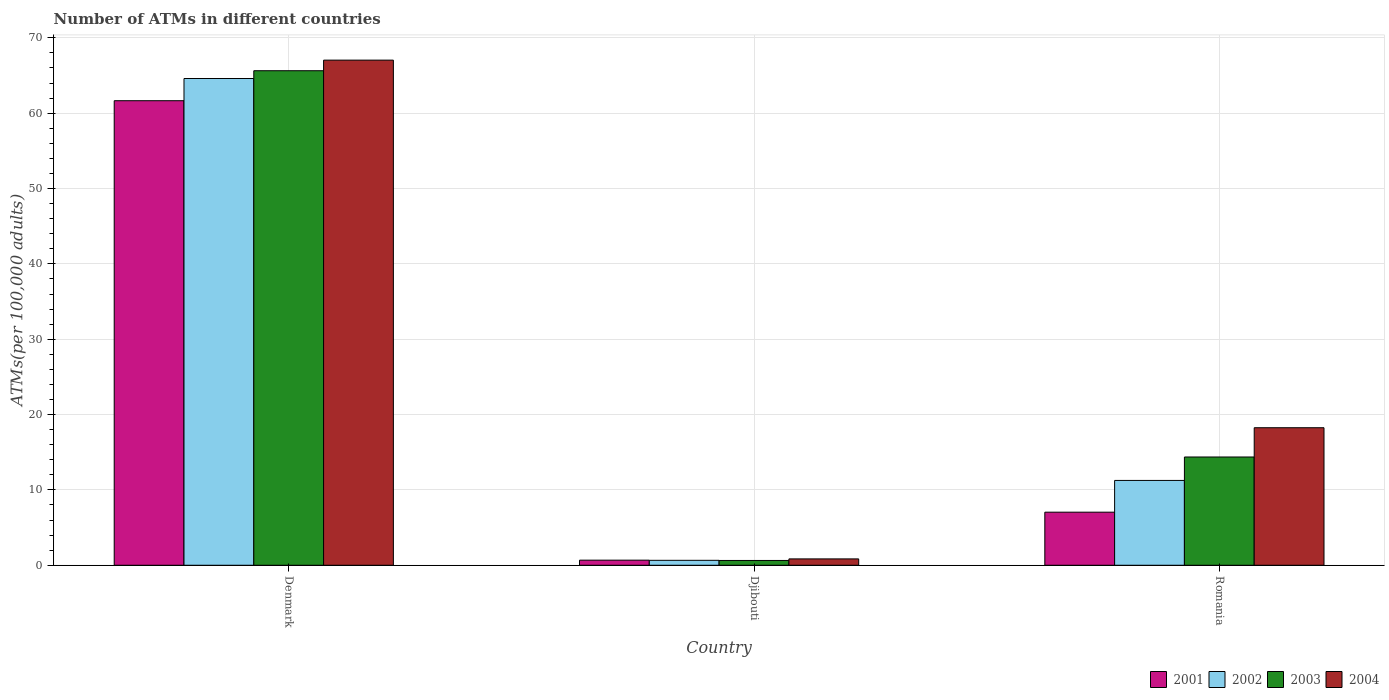How many groups of bars are there?
Your answer should be very brief. 3. Are the number of bars on each tick of the X-axis equal?
Make the answer very short. Yes. How many bars are there on the 2nd tick from the right?
Your answer should be compact. 4. What is the label of the 2nd group of bars from the left?
Ensure brevity in your answer.  Djibouti. What is the number of ATMs in 2004 in Romania?
Your response must be concise. 18.26. Across all countries, what is the maximum number of ATMs in 2002?
Keep it short and to the point. 64.61. Across all countries, what is the minimum number of ATMs in 2001?
Offer a terse response. 0.68. In which country was the number of ATMs in 2002 maximum?
Give a very brief answer. Denmark. In which country was the number of ATMs in 2002 minimum?
Your answer should be very brief. Djibouti. What is the total number of ATMs in 2003 in the graph?
Your response must be concise. 80.65. What is the difference between the number of ATMs in 2003 in Djibouti and that in Romania?
Give a very brief answer. -13.73. What is the difference between the number of ATMs in 2001 in Denmark and the number of ATMs in 2002 in Romania?
Offer a terse response. 50.4. What is the average number of ATMs in 2001 per country?
Provide a short and direct response. 23.13. What is the difference between the number of ATMs of/in 2001 and number of ATMs of/in 2002 in Djibouti?
Ensure brevity in your answer.  0.02. What is the ratio of the number of ATMs in 2003 in Djibouti to that in Romania?
Your answer should be very brief. 0.04. Is the number of ATMs in 2004 in Djibouti less than that in Romania?
Offer a terse response. Yes. What is the difference between the highest and the second highest number of ATMs in 2004?
Offer a very short reply. -17.41. What is the difference between the highest and the lowest number of ATMs in 2002?
Your response must be concise. 63.95. In how many countries, is the number of ATMs in 2002 greater than the average number of ATMs in 2002 taken over all countries?
Offer a terse response. 1. Is the sum of the number of ATMs in 2001 in Denmark and Djibouti greater than the maximum number of ATMs in 2003 across all countries?
Offer a terse response. No. Is it the case that in every country, the sum of the number of ATMs in 2001 and number of ATMs in 2003 is greater than the sum of number of ATMs in 2004 and number of ATMs in 2002?
Give a very brief answer. No. What does the 2nd bar from the left in Djibouti represents?
Your response must be concise. 2002. What does the 4th bar from the right in Djibouti represents?
Your answer should be compact. 2001. Is it the case that in every country, the sum of the number of ATMs in 2001 and number of ATMs in 2003 is greater than the number of ATMs in 2002?
Your answer should be very brief. Yes. What is the title of the graph?
Give a very brief answer. Number of ATMs in different countries. What is the label or title of the X-axis?
Make the answer very short. Country. What is the label or title of the Y-axis?
Give a very brief answer. ATMs(per 100,0 adults). What is the ATMs(per 100,000 adults) in 2001 in Denmark?
Ensure brevity in your answer.  61.66. What is the ATMs(per 100,000 adults) of 2002 in Denmark?
Your answer should be very brief. 64.61. What is the ATMs(per 100,000 adults) in 2003 in Denmark?
Provide a short and direct response. 65.64. What is the ATMs(per 100,000 adults) of 2004 in Denmark?
Your response must be concise. 67.04. What is the ATMs(per 100,000 adults) in 2001 in Djibouti?
Keep it short and to the point. 0.68. What is the ATMs(per 100,000 adults) of 2002 in Djibouti?
Your answer should be very brief. 0.66. What is the ATMs(per 100,000 adults) in 2003 in Djibouti?
Keep it short and to the point. 0.64. What is the ATMs(per 100,000 adults) in 2004 in Djibouti?
Provide a short and direct response. 0.84. What is the ATMs(per 100,000 adults) in 2001 in Romania?
Provide a short and direct response. 7.04. What is the ATMs(per 100,000 adults) in 2002 in Romania?
Give a very brief answer. 11.26. What is the ATMs(per 100,000 adults) of 2003 in Romania?
Make the answer very short. 14.37. What is the ATMs(per 100,000 adults) of 2004 in Romania?
Offer a very short reply. 18.26. Across all countries, what is the maximum ATMs(per 100,000 adults) in 2001?
Offer a very short reply. 61.66. Across all countries, what is the maximum ATMs(per 100,000 adults) of 2002?
Keep it short and to the point. 64.61. Across all countries, what is the maximum ATMs(per 100,000 adults) of 2003?
Ensure brevity in your answer.  65.64. Across all countries, what is the maximum ATMs(per 100,000 adults) in 2004?
Provide a short and direct response. 67.04. Across all countries, what is the minimum ATMs(per 100,000 adults) of 2001?
Provide a short and direct response. 0.68. Across all countries, what is the minimum ATMs(per 100,000 adults) in 2002?
Give a very brief answer. 0.66. Across all countries, what is the minimum ATMs(per 100,000 adults) of 2003?
Your response must be concise. 0.64. Across all countries, what is the minimum ATMs(per 100,000 adults) of 2004?
Your answer should be compact. 0.84. What is the total ATMs(per 100,000 adults) in 2001 in the graph?
Offer a terse response. 69.38. What is the total ATMs(per 100,000 adults) in 2002 in the graph?
Give a very brief answer. 76.52. What is the total ATMs(per 100,000 adults) of 2003 in the graph?
Your answer should be compact. 80.65. What is the total ATMs(per 100,000 adults) in 2004 in the graph?
Ensure brevity in your answer.  86.14. What is the difference between the ATMs(per 100,000 adults) in 2001 in Denmark and that in Djibouti?
Your answer should be compact. 60.98. What is the difference between the ATMs(per 100,000 adults) of 2002 in Denmark and that in Djibouti?
Ensure brevity in your answer.  63.95. What is the difference between the ATMs(per 100,000 adults) of 2003 in Denmark and that in Djibouti?
Give a very brief answer. 65. What is the difference between the ATMs(per 100,000 adults) of 2004 in Denmark and that in Djibouti?
Ensure brevity in your answer.  66.2. What is the difference between the ATMs(per 100,000 adults) of 2001 in Denmark and that in Romania?
Your response must be concise. 54.61. What is the difference between the ATMs(per 100,000 adults) of 2002 in Denmark and that in Romania?
Give a very brief answer. 53.35. What is the difference between the ATMs(per 100,000 adults) of 2003 in Denmark and that in Romania?
Offer a terse response. 51.27. What is the difference between the ATMs(per 100,000 adults) of 2004 in Denmark and that in Romania?
Provide a succinct answer. 48.79. What is the difference between the ATMs(per 100,000 adults) in 2001 in Djibouti and that in Romania?
Give a very brief answer. -6.37. What is the difference between the ATMs(per 100,000 adults) of 2002 in Djibouti and that in Romania?
Make the answer very short. -10.6. What is the difference between the ATMs(per 100,000 adults) of 2003 in Djibouti and that in Romania?
Provide a short and direct response. -13.73. What is the difference between the ATMs(per 100,000 adults) of 2004 in Djibouti and that in Romania?
Provide a short and direct response. -17.41. What is the difference between the ATMs(per 100,000 adults) of 2001 in Denmark and the ATMs(per 100,000 adults) of 2002 in Djibouti?
Ensure brevity in your answer.  61. What is the difference between the ATMs(per 100,000 adults) of 2001 in Denmark and the ATMs(per 100,000 adults) of 2003 in Djibouti?
Provide a succinct answer. 61.02. What is the difference between the ATMs(per 100,000 adults) of 2001 in Denmark and the ATMs(per 100,000 adults) of 2004 in Djibouti?
Your response must be concise. 60.81. What is the difference between the ATMs(per 100,000 adults) in 2002 in Denmark and the ATMs(per 100,000 adults) in 2003 in Djibouti?
Provide a succinct answer. 63.97. What is the difference between the ATMs(per 100,000 adults) of 2002 in Denmark and the ATMs(per 100,000 adults) of 2004 in Djibouti?
Make the answer very short. 63.76. What is the difference between the ATMs(per 100,000 adults) in 2003 in Denmark and the ATMs(per 100,000 adults) in 2004 in Djibouti?
Your answer should be compact. 64.79. What is the difference between the ATMs(per 100,000 adults) of 2001 in Denmark and the ATMs(per 100,000 adults) of 2002 in Romania?
Your answer should be compact. 50.4. What is the difference between the ATMs(per 100,000 adults) in 2001 in Denmark and the ATMs(per 100,000 adults) in 2003 in Romania?
Give a very brief answer. 47.29. What is the difference between the ATMs(per 100,000 adults) in 2001 in Denmark and the ATMs(per 100,000 adults) in 2004 in Romania?
Your answer should be compact. 43.4. What is the difference between the ATMs(per 100,000 adults) of 2002 in Denmark and the ATMs(per 100,000 adults) of 2003 in Romania?
Ensure brevity in your answer.  50.24. What is the difference between the ATMs(per 100,000 adults) in 2002 in Denmark and the ATMs(per 100,000 adults) in 2004 in Romania?
Provide a short and direct response. 46.35. What is the difference between the ATMs(per 100,000 adults) in 2003 in Denmark and the ATMs(per 100,000 adults) in 2004 in Romania?
Provide a short and direct response. 47.38. What is the difference between the ATMs(per 100,000 adults) of 2001 in Djibouti and the ATMs(per 100,000 adults) of 2002 in Romania?
Provide a short and direct response. -10.58. What is the difference between the ATMs(per 100,000 adults) of 2001 in Djibouti and the ATMs(per 100,000 adults) of 2003 in Romania?
Ensure brevity in your answer.  -13.69. What is the difference between the ATMs(per 100,000 adults) in 2001 in Djibouti and the ATMs(per 100,000 adults) in 2004 in Romania?
Make the answer very short. -17.58. What is the difference between the ATMs(per 100,000 adults) of 2002 in Djibouti and the ATMs(per 100,000 adults) of 2003 in Romania?
Keep it short and to the point. -13.71. What is the difference between the ATMs(per 100,000 adults) in 2002 in Djibouti and the ATMs(per 100,000 adults) in 2004 in Romania?
Provide a succinct answer. -17.6. What is the difference between the ATMs(per 100,000 adults) of 2003 in Djibouti and the ATMs(per 100,000 adults) of 2004 in Romania?
Offer a very short reply. -17.62. What is the average ATMs(per 100,000 adults) in 2001 per country?
Your answer should be very brief. 23.13. What is the average ATMs(per 100,000 adults) in 2002 per country?
Ensure brevity in your answer.  25.51. What is the average ATMs(per 100,000 adults) of 2003 per country?
Provide a succinct answer. 26.88. What is the average ATMs(per 100,000 adults) of 2004 per country?
Provide a succinct answer. 28.71. What is the difference between the ATMs(per 100,000 adults) of 2001 and ATMs(per 100,000 adults) of 2002 in Denmark?
Your response must be concise. -2.95. What is the difference between the ATMs(per 100,000 adults) in 2001 and ATMs(per 100,000 adults) in 2003 in Denmark?
Provide a short and direct response. -3.98. What is the difference between the ATMs(per 100,000 adults) in 2001 and ATMs(per 100,000 adults) in 2004 in Denmark?
Make the answer very short. -5.39. What is the difference between the ATMs(per 100,000 adults) in 2002 and ATMs(per 100,000 adults) in 2003 in Denmark?
Your response must be concise. -1.03. What is the difference between the ATMs(per 100,000 adults) in 2002 and ATMs(per 100,000 adults) in 2004 in Denmark?
Give a very brief answer. -2.44. What is the difference between the ATMs(per 100,000 adults) of 2003 and ATMs(per 100,000 adults) of 2004 in Denmark?
Offer a terse response. -1.41. What is the difference between the ATMs(per 100,000 adults) of 2001 and ATMs(per 100,000 adults) of 2002 in Djibouti?
Give a very brief answer. 0.02. What is the difference between the ATMs(per 100,000 adults) in 2001 and ATMs(per 100,000 adults) in 2003 in Djibouti?
Give a very brief answer. 0.04. What is the difference between the ATMs(per 100,000 adults) of 2001 and ATMs(per 100,000 adults) of 2004 in Djibouti?
Provide a short and direct response. -0.17. What is the difference between the ATMs(per 100,000 adults) of 2002 and ATMs(per 100,000 adults) of 2003 in Djibouti?
Your response must be concise. 0.02. What is the difference between the ATMs(per 100,000 adults) of 2002 and ATMs(per 100,000 adults) of 2004 in Djibouti?
Offer a terse response. -0.19. What is the difference between the ATMs(per 100,000 adults) in 2003 and ATMs(per 100,000 adults) in 2004 in Djibouti?
Provide a succinct answer. -0.21. What is the difference between the ATMs(per 100,000 adults) of 2001 and ATMs(per 100,000 adults) of 2002 in Romania?
Your answer should be very brief. -4.21. What is the difference between the ATMs(per 100,000 adults) in 2001 and ATMs(per 100,000 adults) in 2003 in Romania?
Make the answer very short. -7.32. What is the difference between the ATMs(per 100,000 adults) in 2001 and ATMs(per 100,000 adults) in 2004 in Romania?
Provide a succinct answer. -11.21. What is the difference between the ATMs(per 100,000 adults) in 2002 and ATMs(per 100,000 adults) in 2003 in Romania?
Ensure brevity in your answer.  -3.11. What is the difference between the ATMs(per 100,000 adults) in 2002 and ATMs(per 100,000 adults) in 2004 in Romania?
Provide a short and direct response. -7. What is the difference between the ATMs(per 100,000 adults) in 2003 and ATMs(per 100,000 adults) in 2004 in Romania?
Your answer should be compact. -3.89. What is the ratio of the ATMs(per 100,000 adults) in 2001 in Denmark to that in Djibouti?
Offer a terse response. 91.18. What is the ratio of the ATMs(per 100,000 adults) of 2002 in Denmark to that in Djibouti?
Ensure brevity in your answer.  98.45. What is the ratio of the ATMs(per 100,000 adults) of 2003 in Denmark to that in Djibouti?
Your response must be concise. 102.88. What is the ratio of the ATMs(per 100,000 adults) of 2004 in Denmark to that in Djibouti?
Your answer should be compact. 79.46. What is the ratio of the ATMs(per 100,000 adults) in 2001 in Denmark to that in Romania?
Keep it short and to the point. 8.75. What is the ratio of the ATMs(per 100,000 adults) of 2002 in Denmark to that in Romania?
Offer a terse response. 5.74. What is the ratio of the ATMs(per 100,000 adults) of 2003 in Denmark to that in Romania?
Provide a short and direct response. 4.57. What is the ratio of the ATMs(per 100,000 adults) in 2004 in Denmark to that in Romania?
Make the answer very short. 3.67. What is the ratio of the ATMs(per 100,000 adults) in 2001 in Djibouti to that in Romania?
Keep it short and to the point. 0.1. What is the ratio of the ATMs(per 100,000 adults) in 2002 in Djibouti to that in Romania?
Make the answer very short. 0.06. What is the ratio of the ATMs(per 100,000 adults) in 2003 in Djibouti to that in Romania?
Provide a succinct answer. 0.04. What is the ratio of the ATMs(per 100,000 adults) of 2004 in Djibouti to that in Romania?
Offer a very short reply. 0.05. What is the difference between the highest and the second highest ATMs(per 100,000 adults) in 2001?
Keep it short and to the point. 54.61. What is the difference between the highest and the second highest ATMs(per 100,000 adults) of 2002?
Ensure brevity in your answer.  53.35. What is the difference between the highest and the second highest ATMs(per 100,000 adults) in 2003?
Provide a short and direct response. 51.27. What is the difference between the highest and the second highest ATMs(per 100,000 adults) of 2004?
Your answer should be very brief. 48.79. What is the difference between the highest and the lowest ATMs(per 100,000 adults) of 2001?
Ensure brevity in your answer.  60.98. What is the difference between the highest and the lowest ATMs(per 100,000 adults) in 2002?
Keep it short and to the point. 63.95. What is the difference between the highest and the lowest ATMs(per 100,000 adults) in 2003?
Give a very brief answer. 65. What is the difference between the highest and the lowest ATMs(per 100,000 adults) of 2004?
Your response must be concise. 66.2. 